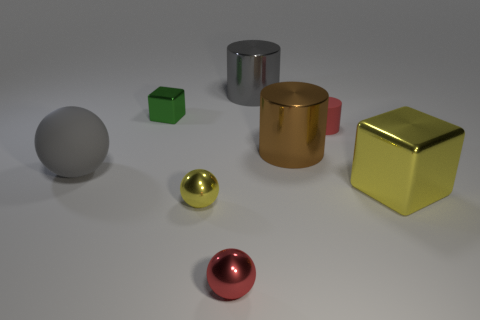Subtract all red shiny balls. How many balls are left? 2 Add 1 metal balls. How many objects exist? 9 Subtract all yellow blocks. How many blocks are left? 1 Subtract all cylinders. How many objects are left? 5 Subtract 1 cylinders. How many cylinders are left? 2 Subtract all matte objects. Subtract all cylinders. How many objects are left? 3 Add 5 large metal things. How many large metal things are left? 8 Add 5 tiny red spheres. How many tiny red spheres exist? 6 Subtract 0 blue spheres. How many objects are left? 8 Subtract all purple blocks. Subtract all cyan cylinders. How many blocks are left? 2 